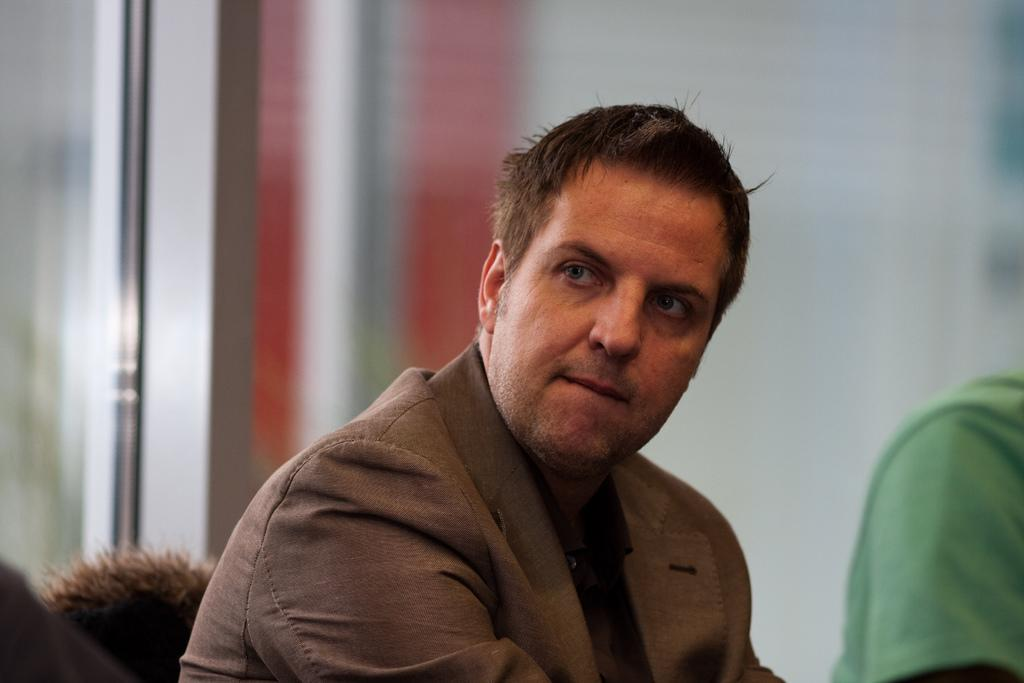What is the person in the chair doing? The person is sitting in the chair. What can be observed about the person's clothing? The person is wearing a brown color coat. How many people are sitting in the image? There are two people sitting in the image. Can you describe the background of the image? The background of the image is blurred. Is there any snow visible in the image? There is no snow present in the image. What type of wool is being used to make the coat worn by the person in the chair? The provided facts do not mention the material of the coat, so it cannot be determined if wool is being used. 